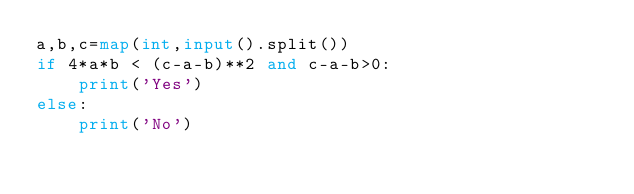<code> <loc_0><loc_0><loc_500><loc_500><_Python_>a,b,c=map(int,input().split())
if 4*a*b < (c-a-b)**2 and c-a-b>0:
    print('Yes')
else:
    print('No')</code> 